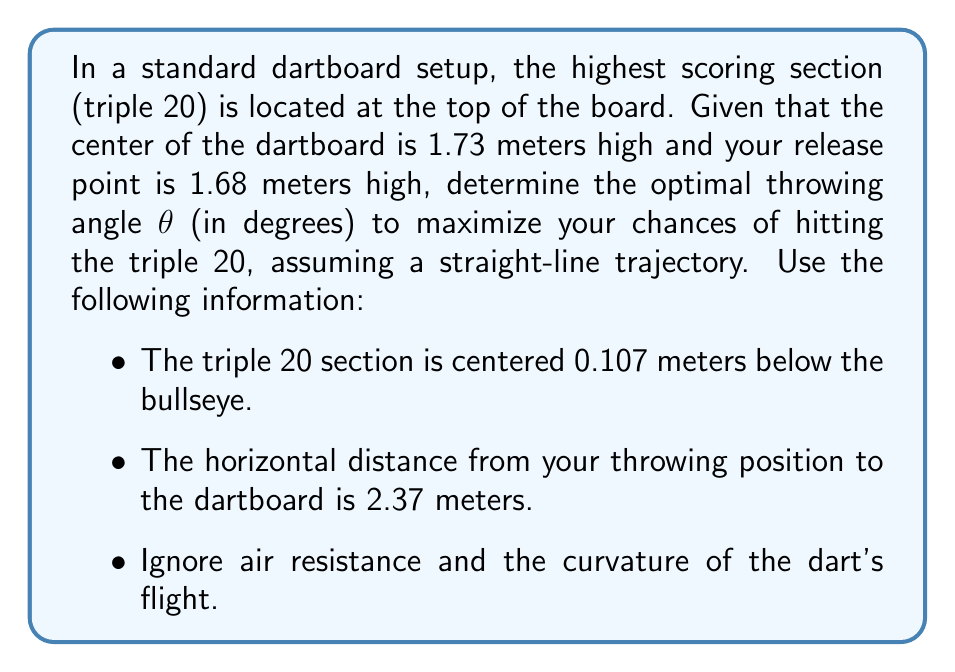Give your solution to this math problem. Let's approach this step-by-step using linear algebra:

1) First, we need to set up our coordinate system. Let's use the release point as our origin (0, 0).

2) The center of the dartboard will be at coordinates (2.37, 0.05), since:
   $0.05 = 1.73 - 1.68$ (height difference)

3) The center of the triple 20 section will be at (2.37, -0.057), since:
   $-0.057 = 0.05 - 0.107$ (0.107 meters below the bullseye)

4) We can represent the dart's trajectory as a vector $\vec{v} = (x, y)$. The optimal angle will be when this vector points directly at the center of the triple 20.

5) To find this vector, we subtract the release point coordinates from the triple 20 coordinates:
   $\vec{v} = (2.37 - 0, -0.057 - 0) = (2.37, -0.057)$

6) Now we can use the arctangent function to find the angle:
   $\theta = \arctan(\frac{y}{x}) = \arctan(\frac{-0.057}{2.37})$

7) Convert from radians to degrees:
   $\theta = \arctan(\frac{-0.057}{2.37}) \cdot \frac{180}{\pi}$

8) Calculating this:
   $\theta \approx -1.3778$ degrees

9) Since we're throwing upwards, we need the positive angle:
   $\theta \approx 1.3778$ degrees
Answer: $1.38°$ (rounded to two decimal places) 